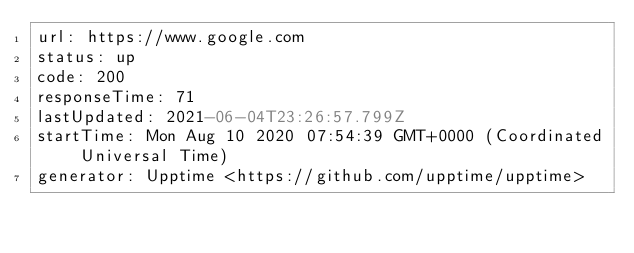Convert code to text. <code><loc_0><loc_0><loc_500><loc_500><_YAML_>url: https://www.google.com
status: up
code: 200
responseTime: 71
lastUpdated: 2021-06-04T23:26:57.799Z
startTime: Mon Aug 10 2020 07:54:39 GMT+0000 (Coordinated Universal Time)
generator: Upptime <https://github.com/upptime/upptime>
</code> 